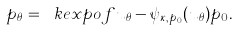<formula> <loc_0><loc_0><loc_500><loc_500>p _ { \theta } = \ k e x p o f { u _ { \theta } - \psi _ { \kappa , p _ { 0 } } ( u _ { \theta } ) } p _ { 0 } .</formula> 